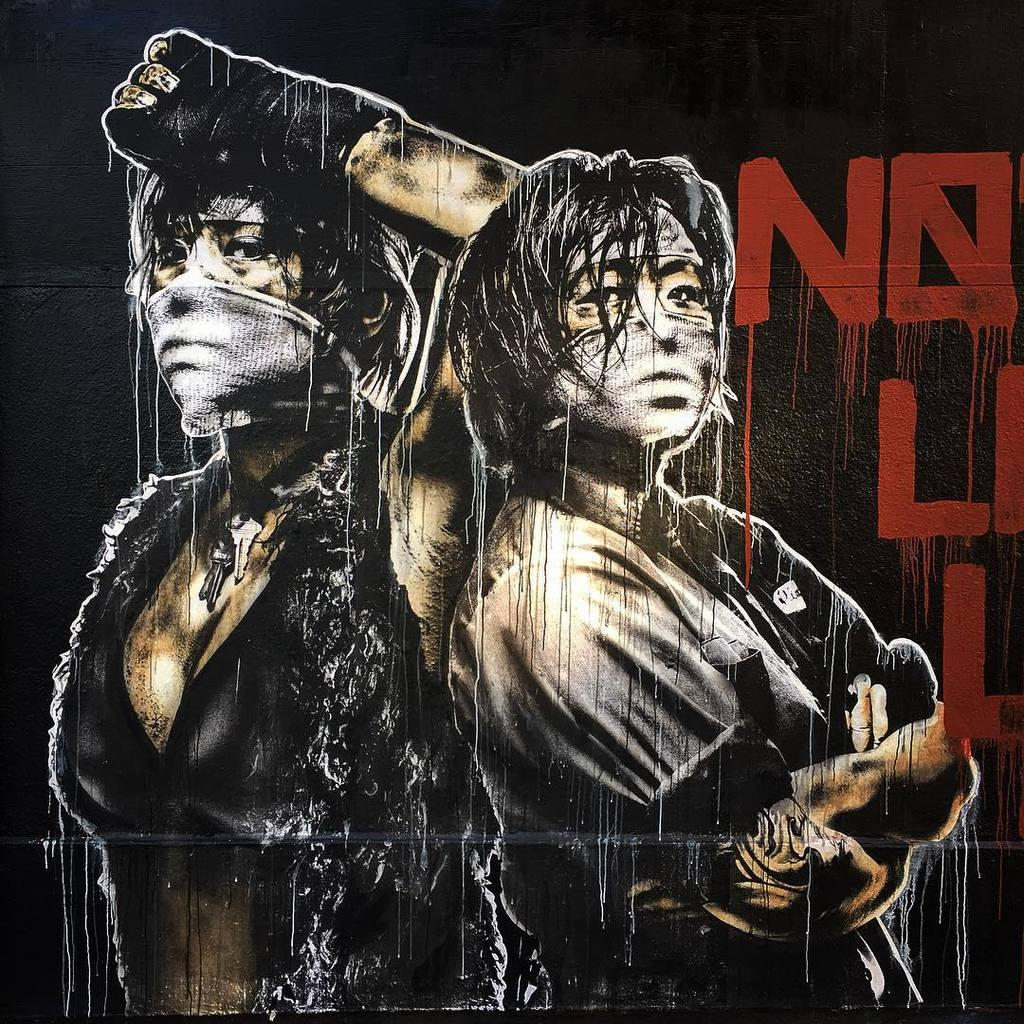What is present in the image that contains visual information? There is a poster in the image. What type of images can be seen on the poster? The poster contains images of persons. Is there any text present on the poster? Yes, there is text on the poster. What type of pear is depicted in the image? There is no pear present in the image; it features a poster with images of persons and text. How many birds can be seen flying in the image? There are no birds present in the image; it features a poster with images of persons and text. 